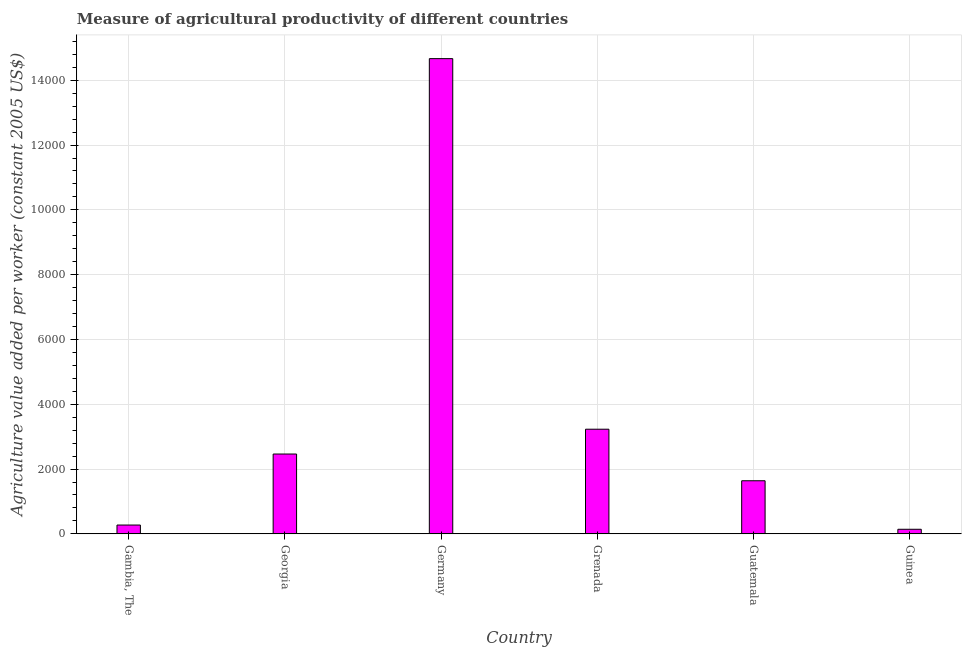Does the graph contain any zero values?
Offer a terse response. No. What is the title of the graph?
Make the answer very short. Measure of agricultural productivity of different countries. What is the label or title of the X-axis?
Provide a succinct answer. Country. What is the label or title of the Y-axis?
Keep it short and to the point. Agriculture value added per worker (constant 2005 US$). What is the agriculture value added per worker in Gambia, The?
Your response must be concise. 272.38. Across all countries, what is the maximum agriculture value added per worker?
Provide a short and direct response. 1.47e+04. Across all countries, what is the minimum agriculture value added per worker?
Your response must be concise. 141.54. In which country was the agriculture value added per worker maximum?
Offer a very short reply. Germany. In which country was the agriculture value added per worker minimum?
Make the answer very short. Guinea. What is the sum of the agriculture value added per worker?
Your response must be concise. 2.24e+04. What is the difference between the agriculture value added per worker in Georgia and Guatemala?
Offer a terse response. 824.8. What is the average agriculture value added per worker per country?
Provide a succinct answer. 3735.72. What is the median agriculture value added per worker?
Your answer should be compact. 2051.57. In how many countries, is the agriculture value added per worker greater than 9200 US$?
Give a very brief answer. 1. What is the ratio of the agriculture value added per worker in Gambia, The to that in Germany?
Make the answer very short. 0.02. What is the difference between the highest and the second highest agriculture value added per worker?
Keep it short and to the point. 1.14e+04. What is the difference between the highest and the lowest agriculture value added per worker?
Make the answer very short. 1.45e+04. In how many countries, is the agriculture value added per worker greater than the average agriculture value added per worker taken over all countries?
Your response must be concise. 1. How many countries are there in the graph?
Provide a short and direct response. 6. What is the difference between two consecutive major ticks on the Y-axis?
Your answer should be very brief. 2000. What is the Agriculture value added per worker (constant 2005 US$) in Gambia, The?
Make the answer very short. 272.38. What is the Agriculture value added per worker (constant 2005 US$) in Georgia?
Offer a very short reply. 2463.97. What is the Agriculture value added per worker (constant 2005 US$) in Germany?
Offer a very short reply. 1.47e+04. What is the Agriculture value added per worker (constant 2005 US$) in Grenada?
Give a very brief answer. 3229.96. What is the Agriculture value added per worker (constant 2005 US$) of Guatemala?
Ensure brevity in your answer.  1639.16. What is the Agriculture value added per worker (constant 2005 US$) of Guinea?
Give a very brief answer. 141.54. What is the difference between the Agriculture value added per worker (constant 2005 US$) in Gambia, The and Georgia?
Keep it short and to the point. -2191.59. What is the difference between the Agriculture value added per worker (constant 2005 US$) in Gambia, The and Germany?
Give a very brief answer. -1.44e+04. What is the difference between the Agriculture value added per worker (constant 2005 US$) in Gambia, The and Grenada?
Provide a short and direct response. -2957.59. What is the difference between the Agriculture value added per worker (constant 2005 US$) in Gambia, The and Guatemala?
Ensure brevity in your answer.  -1366.79. What is the difference between the Agriculture value added per worker (constant 2005 US$) in Gambia, The and Guinea?
Your answer should be very brief. 130.84. What is the difference between the Agriculture value added per worker (constant 2005 US$) in Georgia and Germany?
Ensure brevity in your answer.  -1.22e+04. What is the difference between the Agriculture value added per worker (constant 2005 US$) in Georgia and Grenada?
Give a very brief answer. -766. What is the difference between the Agriculture value added per worker (constant 2005 US$) in Georgia and Guatemala?
Offer a very short reply. 824.8. What is the difference between the Agriculture value added per worker (constant 2005 US$) in Georgia and Guinea?
Make the answer very short. 2322.43. What is the difference between the Agriculture value added per worker (constant 2005 US$) in Germany and Grenada?
Your response must be concise. 1.14e+04. What is the difference between the Agriculture value added per worker (constant 2005 US$) in Germany and Guatemala?
Your response must be concise. 1.30e+04. What is the difference between the Agriculture value added per worker (constant 2005 US$) in Germany and Guinea?
Offer a terse response. 1.45e+04. What is the difference between the Agriculture value added per worker (constant 2005 US$) in Grenada and Guatemala?
Your response must be concise. 1590.8. What is the difference between the Agriculture value added per worker (constant 2005 US$) in Grenada and Guinea?
Your response must be concise. 3088.43. What is the difference between the Agriculture value added per worker (constant 2005 US$) in Guatemala and Guinea?
Give a very brief answer. 1497.63. What is the ratio of the Agriculture value added per worker (constant 2005 US$) in Gambia, The to that in Georgia?
Offer a very short reply. 0.11. What is the ratio of the Agriculture value added per worker (constant 2005 US$) in Gambia, The to that in Germany?
Offer a terse response. 0.02. What is the ratio of the Agriculture value added per worker (constant 2005 US$) in Gambia, The to that in Grenada?
Your response must be concise. 0.08. What is the ratio of the Agriculture value added per worker (constant 2005 US$) in Gambia, The to that in Guatemala?
Give a very brief answer. 0.17. What is the ratio of the Agriculture value added per worker (constant 2005 US$) in Gambia, The to that in Guinea?
Provide a short and direct response. 1.92. What is the ratio of the Agriculture value added per worker (constant 2005 US$) in Georgia to that in Germany?
Offer a terse response. 0.17. What is the ratio of the Agriculture value added per worker (constant 2005 US$) in Georgia to that in Grenada?
Ensure brevity in your answer.  0.76. What is the ratio of the Agriculture value added per worker (constant 2005 US$) in Georgia to that in Guatemala?
Give a very brief answer. 1.5. What is the ratio of the Agriculture value added per worker (constant 2005 US$) in Georgia to that in Guinea?
Make the answer very short. 17.41. What is the ratio of the Agriculture value added per worker (constant 2005 US$) in Germany to that in Grenada?
Your answer should be compact. 4.54. What is the ratio of the Agriculture value added per worker (constant 2005 US$) in Germany to that in Guatemala?
Keep it short and to the point. 8.95. What is the ratio of the Agriculture value added per worker (constant 2005 US$) in Germany to that in Guinea?
Provide a short and direct response. 103.63. What is the ratio of the Agriculture value added per worker (constant 2005 US$) in Grenada to that in Guatemala?
Provide a short and direct response. 1.97. What is the ratio of the Agriculture value added per worker (constant 2005 US$) in Grenada to that in Guinea?
Your answer should be compact. 22.82. What is the ratio of the Agriculture value added per worker (constant 2005 US$) in Guatemala to that in Guinea?
Offer a terse response. 11.58. 